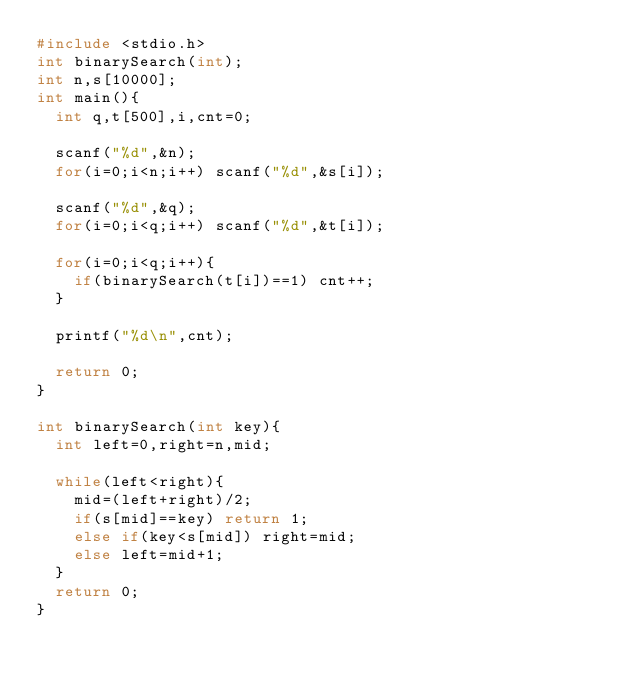Convert code to text. <code><loc_0><loc_0><loc_500><loc_500><_C_>#include <stdio.h>
int binarySearch(int);
int n,s[10000];
int main(){
	int q,t[500],i,cnt=0;
	
	scanf("%d",&n);
	for(i=0;i<n;i++) scanf("%d",&s[i]);

	scanf("%d",&q);
	for(i=0;i<q;i++) scanf("%d",&t[i]);
	
	for(i=0;i<q;i++){
		if(binarySearch(t[i])==1) cnt++;
	}
	
	printf("%d\n",cnt);
	
	return 0;
}

int binarySearch(int key){
	int left=0,right=n,mid;
	
	while(left<right){
		mid=(left+right)/2;
		if(s[mid]==key) return 1;
		else if(key<s[mid]) right=mid;
		else left=mid+1;
	}
	return 0;
}
	
</code> 